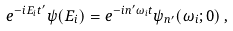Convert formula to latex. <formula><loc_0><loc_0><loc_500><loc_500>e ^ { - i E _ { i } t ^ { \prime } } \psi ( E _ { i } ) = e ^ { - i n ^ { \prime } \omega _ { i } t } \psi _ { n ^ { \prime } } ( \omega _ { i } ; 0 ) \, ,</formula> 